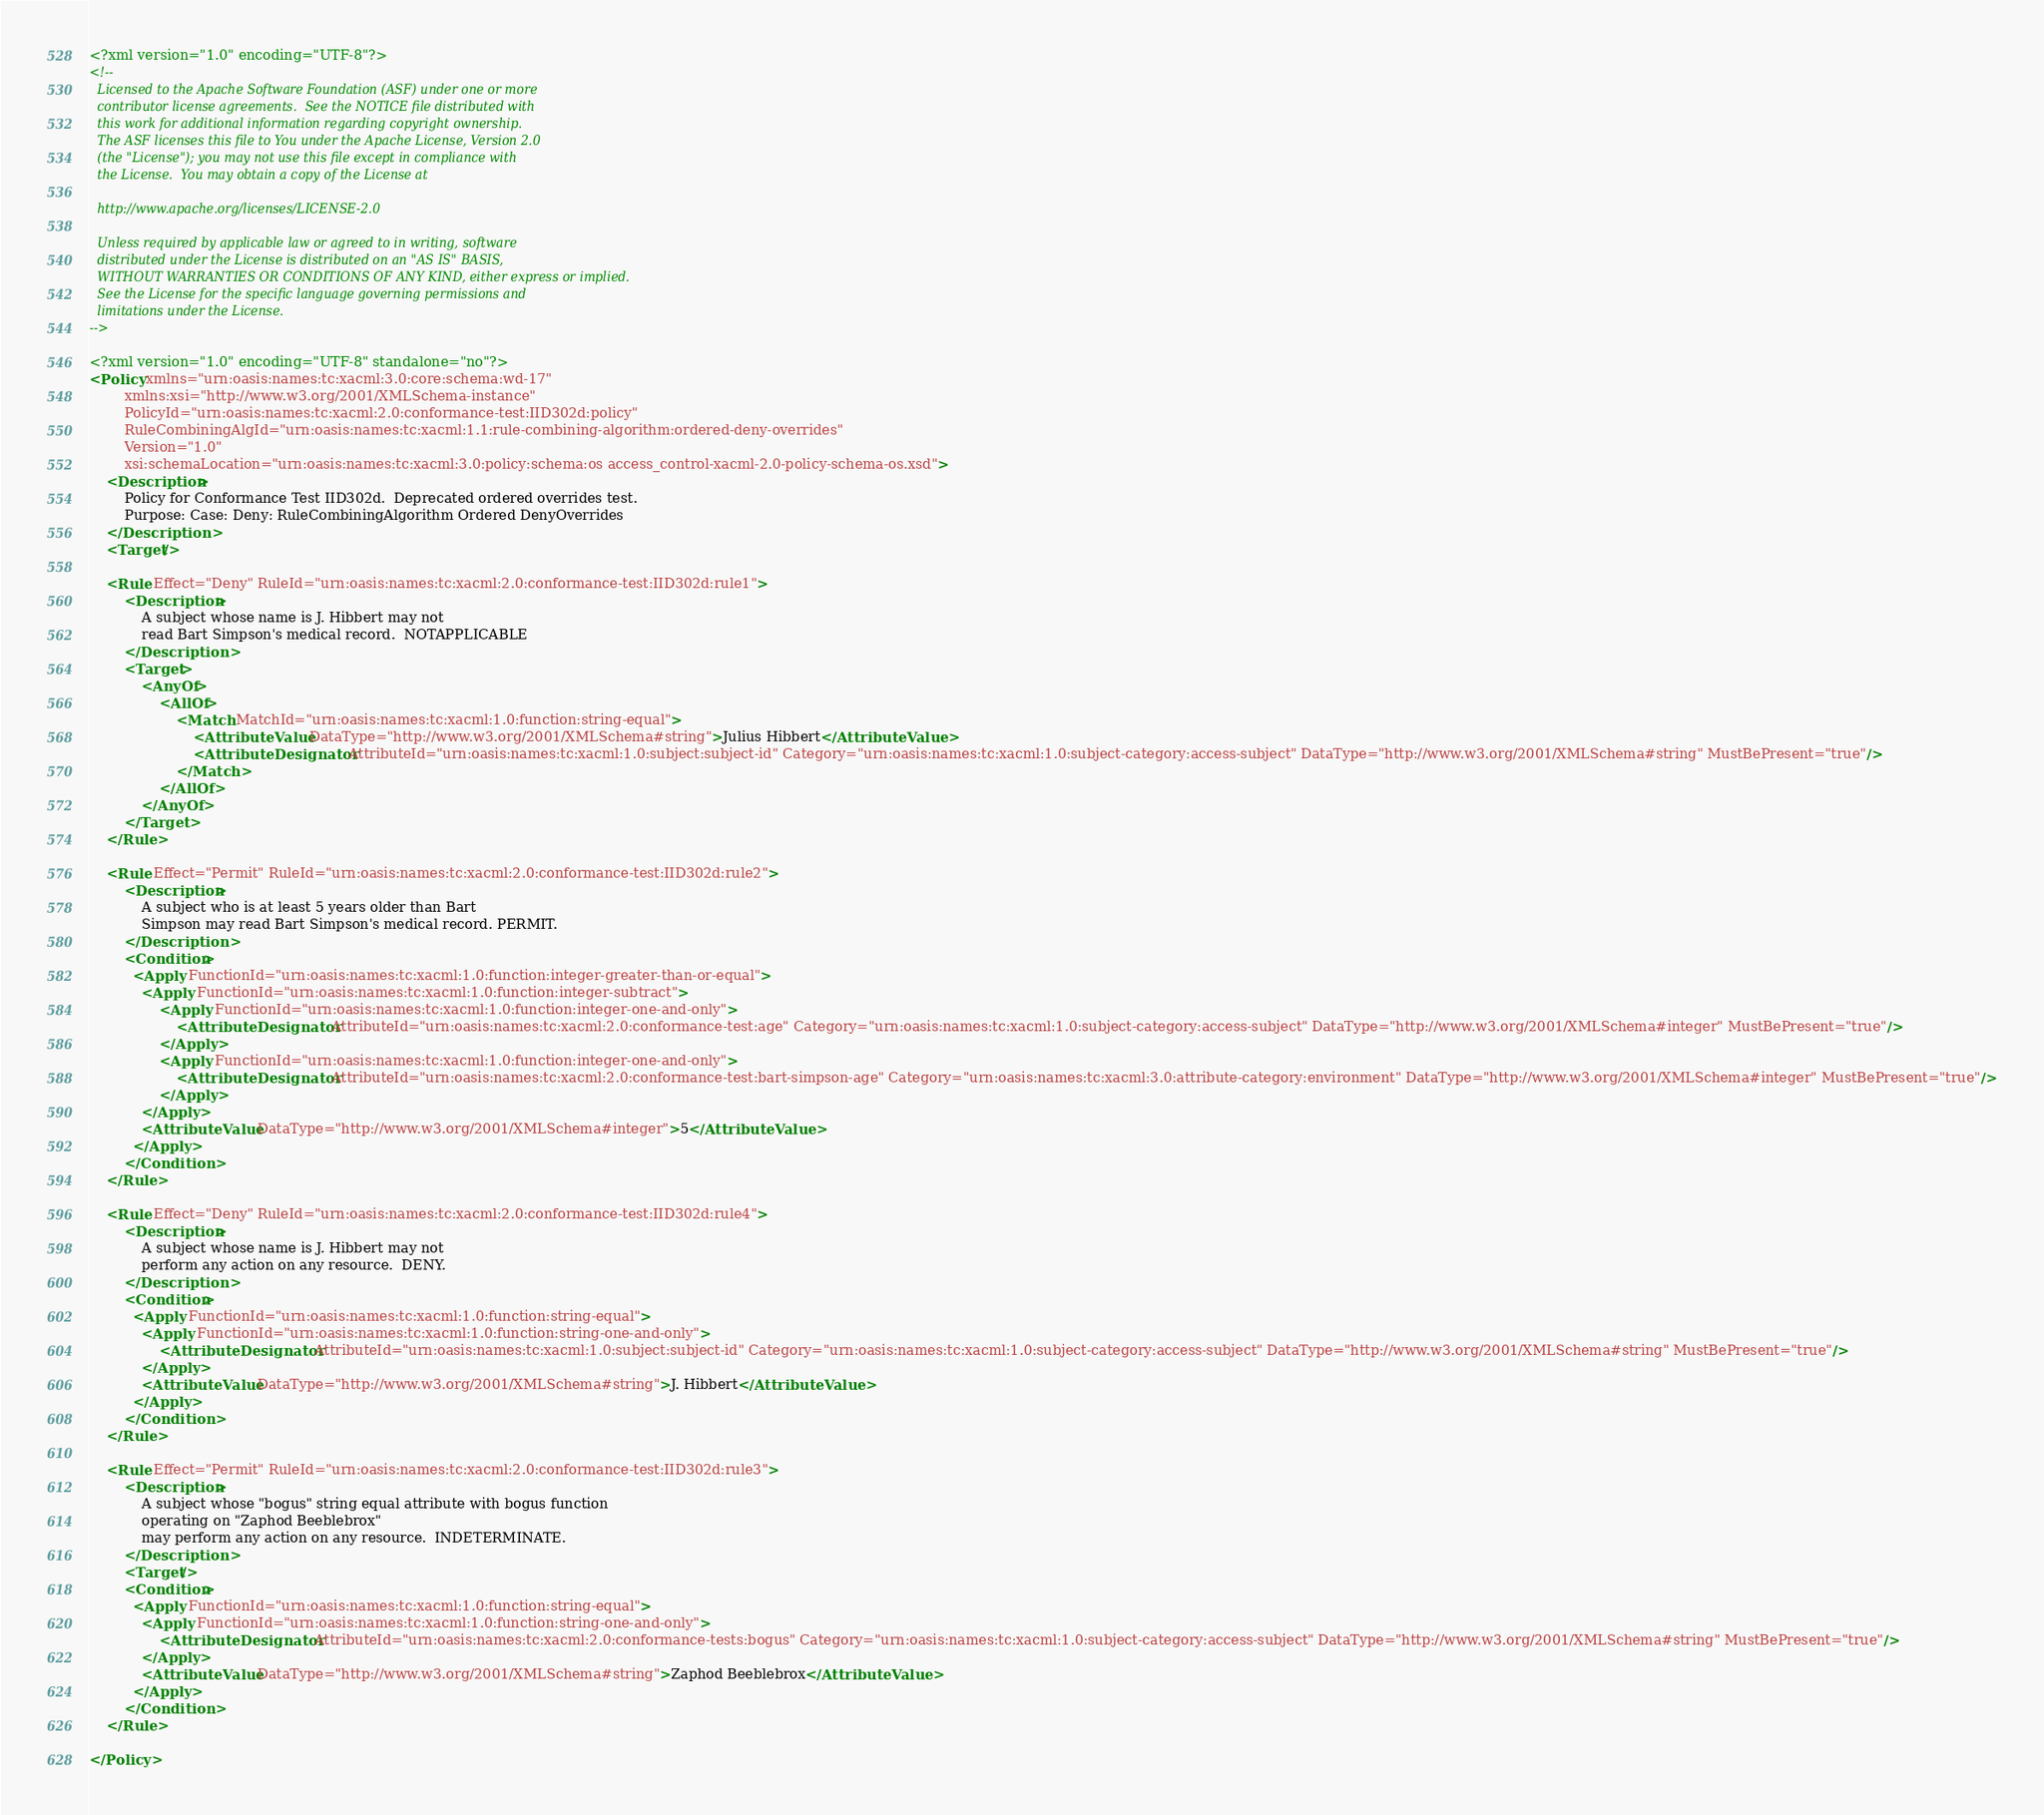Convert code to text. <code><loc_0><loc_0><loc_500><loc_500><_XML_><?xml version="1.0" encoding="UTF-8"?>
<!--
  Licensed to the Apache Software Foundation (ASF) under one or more
  contributor license agreements.  See the NOTICE file distributed with
  this work for additional information regarding copyright ownership.
  The ASF licenses this file to You under the Apache License, Version 2.0
  (the "License"); you may not use this file except in compliance with
  the License.  You may obtain a copy of the License at

  http://www.apache.org/licenses/LICENSE-2.0

  Unless required by applicable law or agreed to in writing, software
  distributed under the License is distributed on an "AS IS" BASIS,
  WITHOUT WARRANTIES OR CONDITIONS OF ANY KIND, either express or implied.
  See the License for the specific language governing permissions and
  limitations under the License.
-->

<?xml version="1.0" encoding="UTF-8" standalone="no"?>
<Policy xmlns="urn:oasis:names:tc:xacml:3.0:core:schema:wd-17" 
		xmlns:xsi="http://www.w3.org/2001/XMLSchema-instance" 
		PolicyId="urn:oasis:names:tc:xacml:2.0:conformance-test:IID302d:policy" 
		RuleCombiningAlgId="urn:oasis:names:tc:xacml:1.1:rule-combining-algorithm:ordered-deny-overrides" 
		Version="1.0" 
		xsi:schemaLocation="urn:oasis:names:tc:xacml:3.0:policy:schema:os access_control-xacml-2.0-policy-schema-os.xsd">
    <Description>
        Policy for Conformance Test IID302d.  Deprecated ordered overrides test.
        Purpose: Case: Deny: RuleCombiningAlgorithm Ordered DenyOverrides
    </Description>
    <Target/>
    
    <Rule Effect="Deny" RuleId="urn:oasis:names:tc:xacml:2.0:conformance-test:IID302d:rule1">
        <Description>
            A subject whose name is J. Hibbert may not
            read Bart Simpson's medical record.  NOTAPPLICABLE
        </Description>
        <Target>
            <AnyOf>
                <AllOf>
                    <Match MatchId="urn:oasis:names:tc:xacml:1.0:function:string-equal">
                        <AttributeValue DataType="http://www.w3.org/2001/XMLSchema#string">Julius Hibbert</AttributeValue>
                        <AttributeDesignator AttributeId="urn:oasis:names:tc:xacml:1.0:subject:subject-id" Category="urn:oasis:names:tc:xacml:1.0:subject-category:access-subject" DataType="http://www.w3.org/2001/XMLSchema#string" MustBePresent="true"/>
                    </Match>
                </AllOf>
            </AnyOf>
        </Target>
    </Rule>
    
    <Rule Effect="Permit" RuleId="urn:oasis:names:tc:xacml:2.0:conformance-test:IID302d:rule2">
        <Description>
            A subject who is at least 5 years older than Bart
            Simpson may read Bart Simpson's medical record. PERMIT.
        </Description>
        <Condition>
		  <Apply FunctionId="urn:oasis:names:tc:xacml:1.0:function:integer-greater-than-or-equal">
            <Apply FunctionId="urn:oasis:names:tc:xacml:1.0:function:integer-subtract">
                <Apply FunctionId="urn:oasis:names:tc:xacml:1.0:function:integer-one-and-only">
                    <AttributeDesignator AttributeId="urn:oasis:names:tc:xacml:2.0:conformance-test:age" Category="urn:oasis:names:tc:xacml:1.0:subject-category:access-subject" DataType="http://www.w3.org/2001/XMLSchema#integer" MustBePresent="true"/>
                </Apply>
                <Apply FunctionId="urn:oasis:names:tc:xacml:1.0:function:integer-one-and-only">
                    <AttributeDesignator AttributeId="urn:oasis:names:tc:xacml:2.0:conformance-test:bart-simpson-age" Category="urn:oasis:names:tc:xacml:3.0:attribute-category:environment" DataType="http://www.w3.org/2001/XMLSchema#integer" MustBePresent="true"/>
                </Apply>
            </Apply>
            <AttributeValue DataType="http://www.w3.org/2001/XMLSchema#integer">5</AttributeValue>
		  </Apply>
        </Condition>
    </Rule>
    
    <Rule Effect="Deny" RuleId="urn:oasis:names:tc:xacml:2.0:conformance-test:IID302d:rule4">
        <Description>
            A subject whose name is J. Hibbert may not
            perform any action on any resource.  DENY.
        </Description>
        <Condition>
		  <Apply FunctionId="urn:oasis:names:tc:xacml:1.0:function:string-equal">
            <Apply FunctionId="urn:oasis:names:tc:xacml:1.0:function:string-one-and-only">
                <AttributeDesignator AttributeId="urn:oasis:names:tc:xacml:1.0:subject:subject-id" Category="urn:oasis:names:tc:xacml:1.0:subject-category:access-subject" DataType="http://www.w3.org/2001/XMLSchema#string" MustBePresent="true"/>
            </Apply>
            <AttributeValue DataType="http://www.w3.org/2001/XMLSchema#string">J. Hibbert</AttributeValue>
		  </Apply>
        </Condition>
    </Rule>
    
    <Rule Effect="Permit" RuleId="urn:oasis:names:tc:xacml:2.0:conformance-test:IID302d:rule3">
        <Description>
            A subject whose "bogus" string equal attribute with bogus function
            operating on "Zaphod Beeblebrox"
            may perform any action on any resource.  INDETERMINATE.
        </Description>
        <Target/>
        <Condition>
		  <Apply FunctionId="urn:oasis:names:tc:xacml:1.0:function:string-equal">
            <Apply FunctionId="urn:oasis:names:tc:xacml:1.0:function:string-one-and-only">
                <AttributeDesignator AttributeId="urn:oasis:names:tc:xacml:2.0:conformance-tests:bogus" Category="urn:oasis:names:tc:xacml:1.0:subject-category:access-subject" DataType="http://www.w3.org/2001/XMLSchema#string" MustBePresent="true"/>
            </Apply>
            <AttributeValue DataType="http://www.w3.org/2001/XMLSchema#string">Zaphod Beeblebrox</AttributeValue>
		  </Apply>
        </Condition>
    </Rule>
    
</Policy>
</code> 